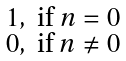Convert formula to latex. <formula><loc_0><loc_0><loc_500><loc_500>\begin{smallmatrix} 1 , & \text {if $n = 0$} \\ 0 , & \text {if $n \neq 0$} \end{smallmatrix}</formula> 